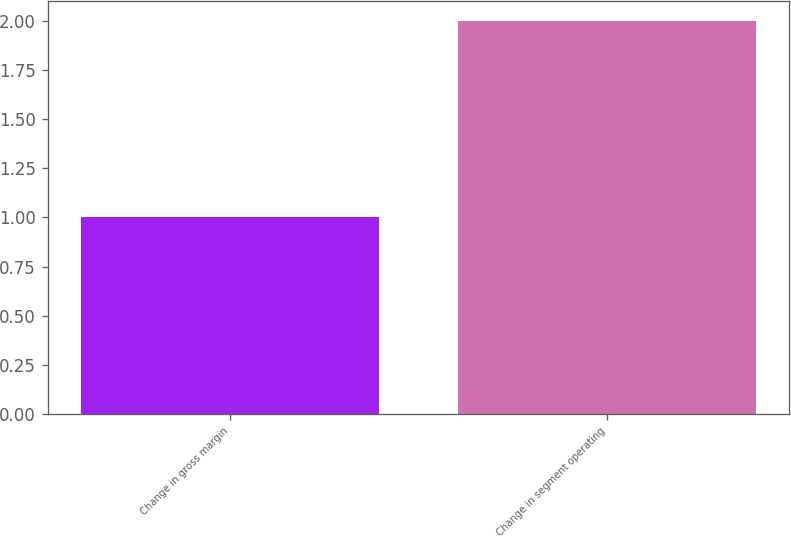Convert chart. <chart><loc_0><loc_0><loc_500><loc_500><bar_chart><fcel>Change in gross margin<fcel>Change in segment operating<nl><fcel>1<fcel>2<nl></chart> 